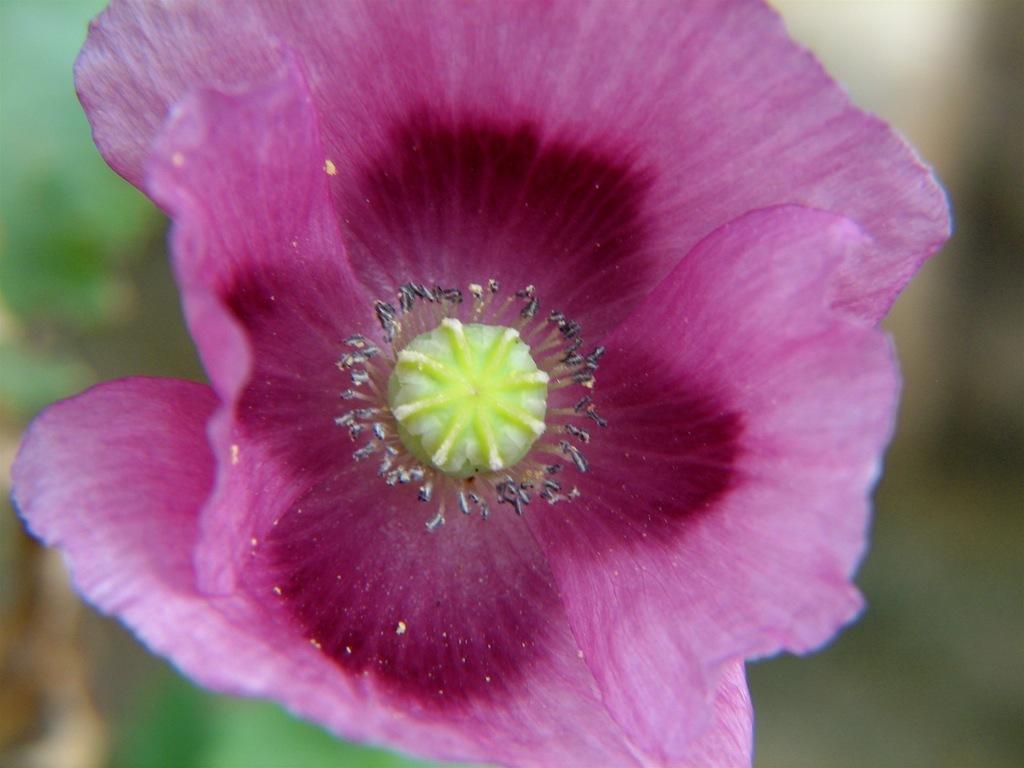How would you summarize this image in a sentence or two? In this image I can see a purple colour flower and here I can see few black colour things. I can also see this image is blurry from background. 